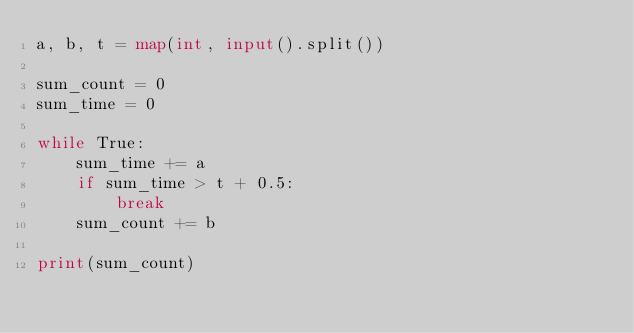<code> <loc_0><loc_0><loc_500><loc_500><_Python_>a, b, t = map(int, input().split())

sum_count = 0
sum_time = 0

while True:
    sum_time += a
    if sum_time > t + 0.5:
        break
    sum_count += b

print(sum_count)</code> 